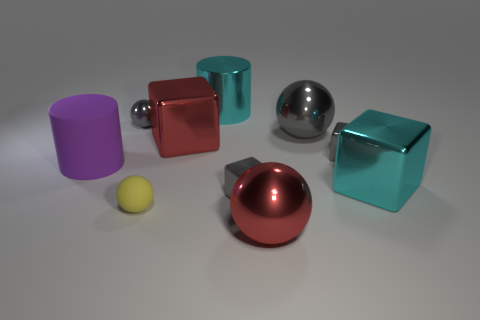Subtract all metallic spheres. How many spheres are left? 1 Subtract all blue cylinders. How many gray cubes are left? 2 Subtract all yellow spheres. How many spheres are left? 3 Subtract all balls. How many objects are left? 6 Add 6 tiny shiny cubes. How many tiny shiny cubes are left? 8 Add 9 yellow shiny blocks. How many yellow shiny blocks exist? 9 Subtract 0 brown cubes. How many objects are left? 10 Subtract all brown blocks. Subtract all blue cylinders. How many blocks are left? 4 Subtract all big yellow matte spheres. Subtract all big red cubes. How many objects are left? 9 